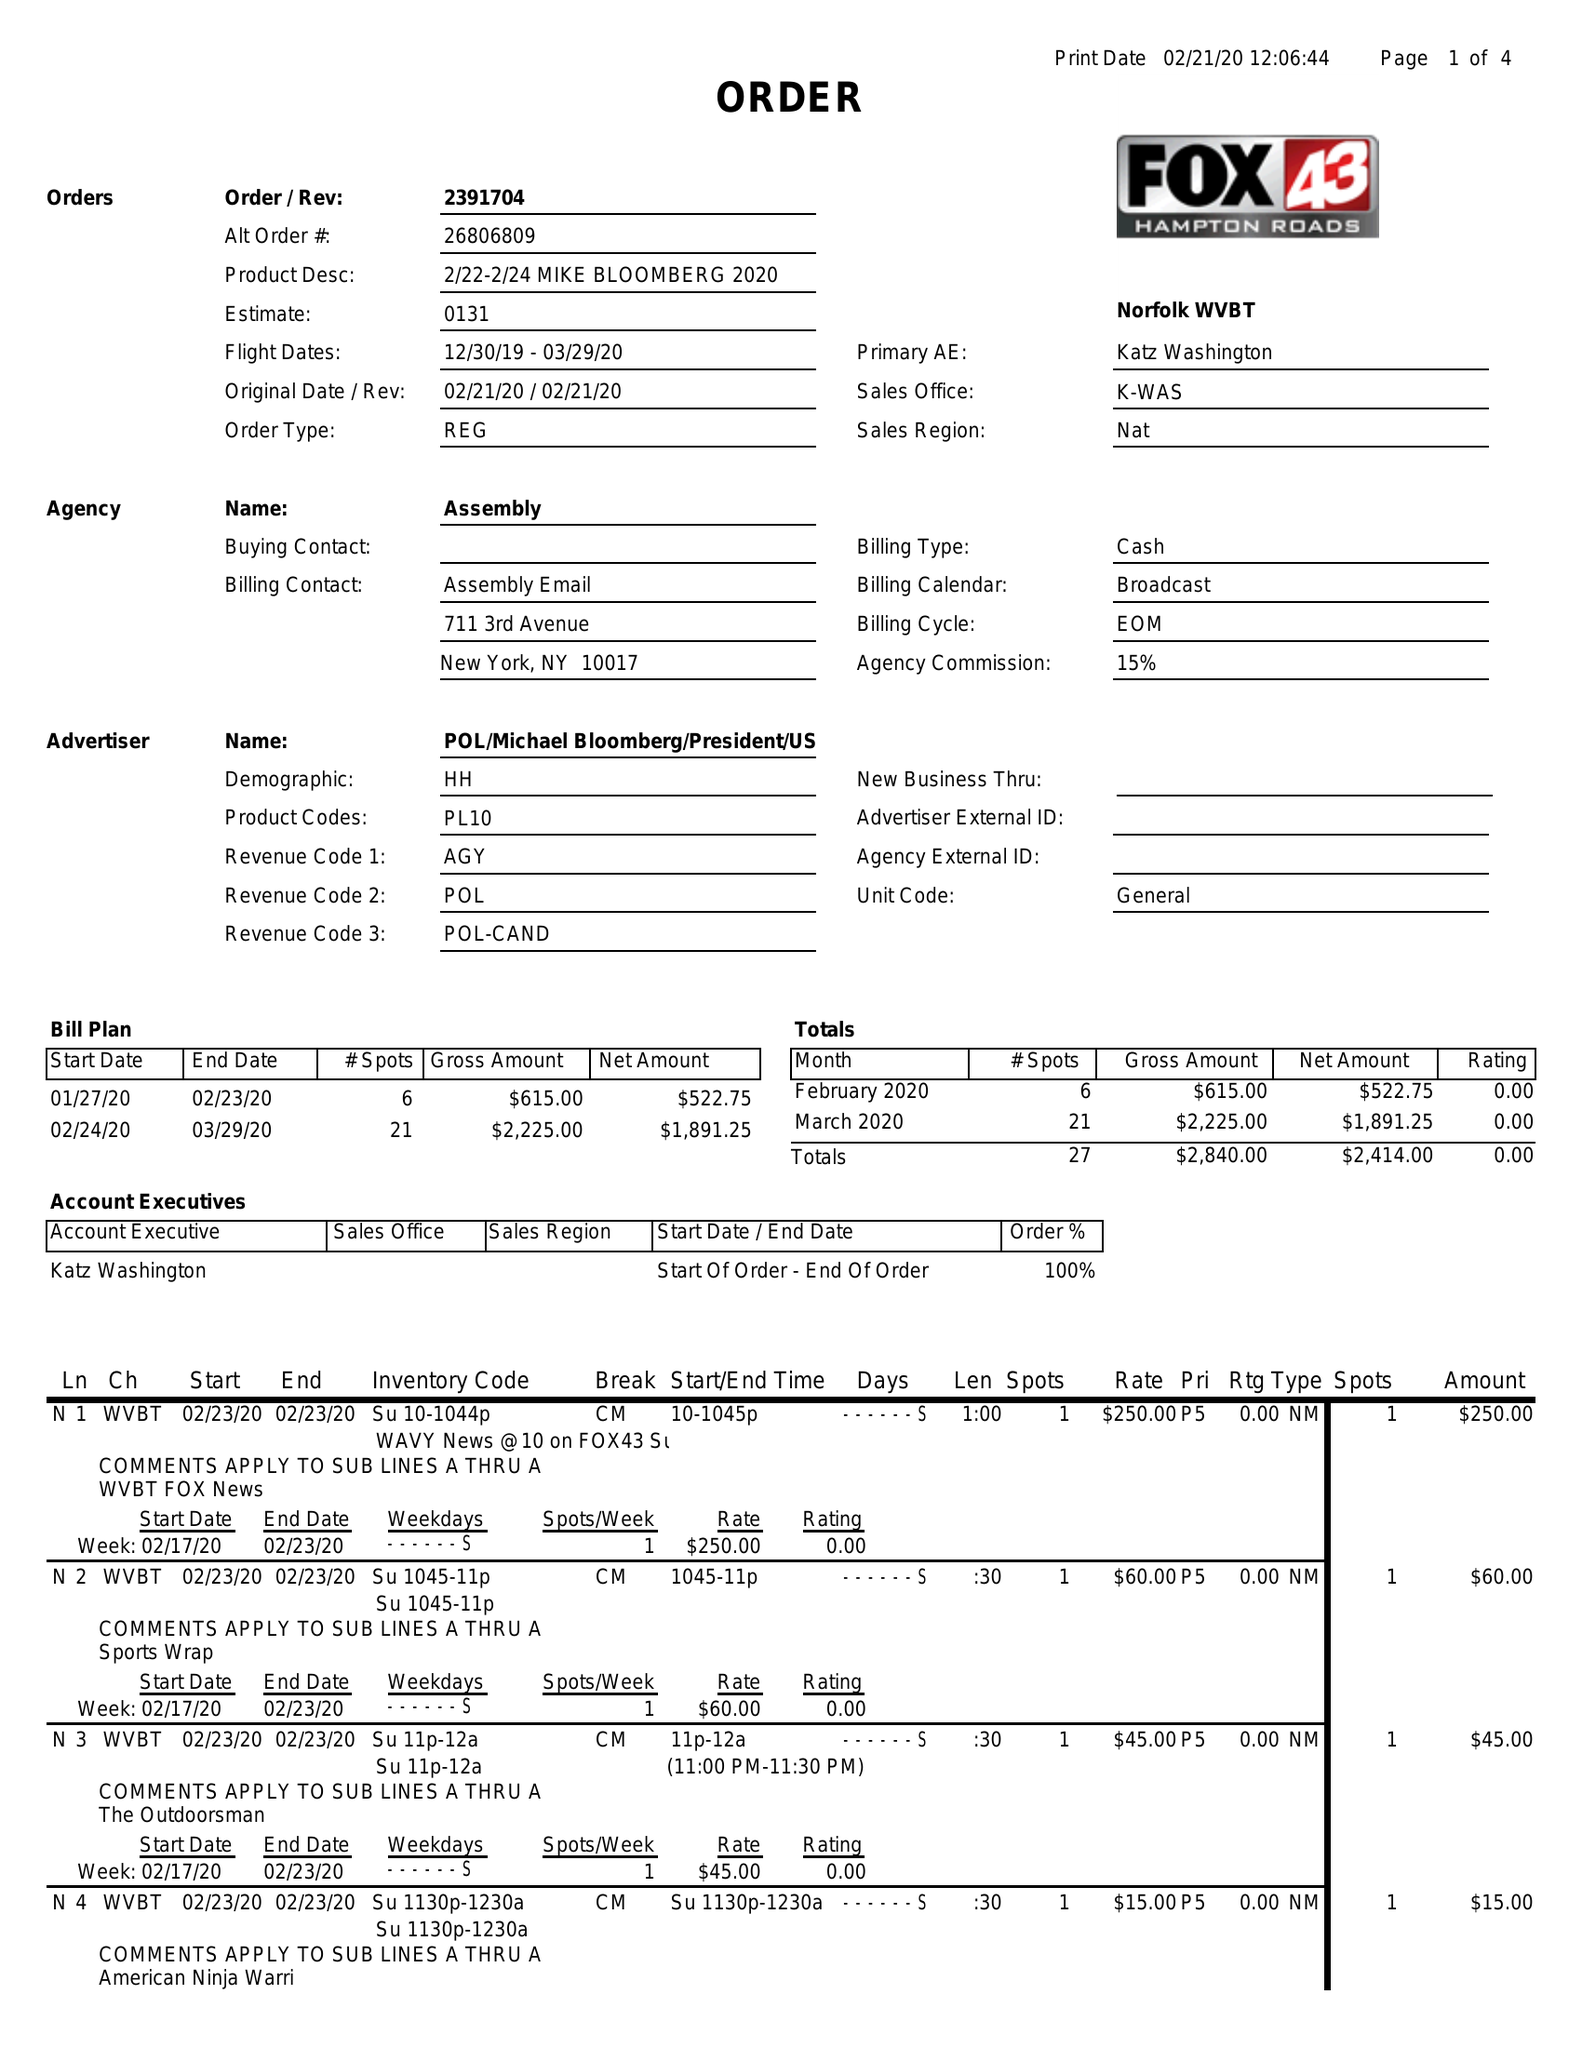What is the value for the gross_amount?
Answer the question using a single word or phrase. 2840.00 